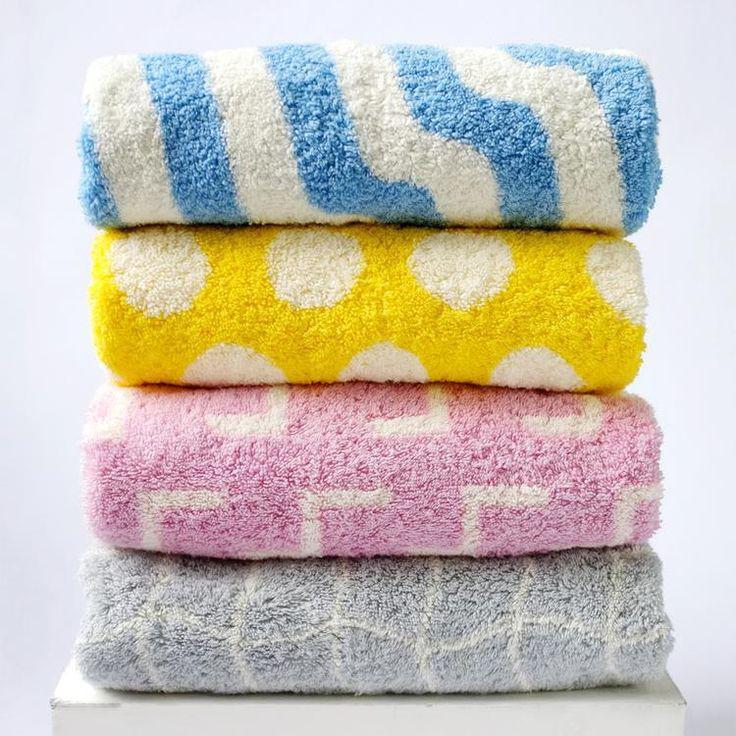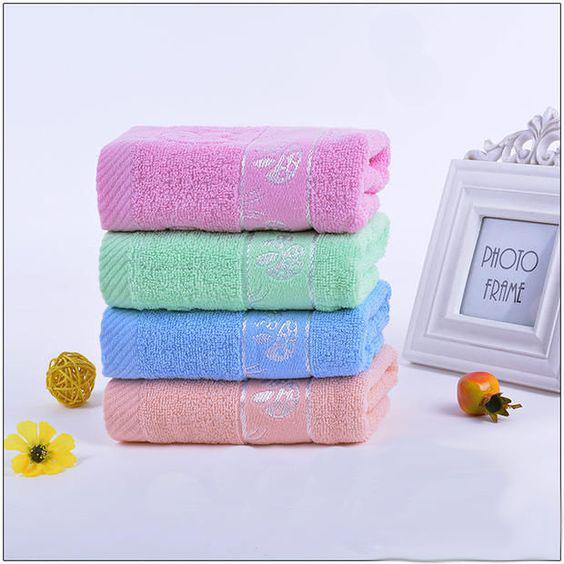The first image is the image on the left, the second image is the image on the right. Considering the images on both sides, is "One image features only solid-colored towels in varying colors." valid? Answer yes or no. Yes. 